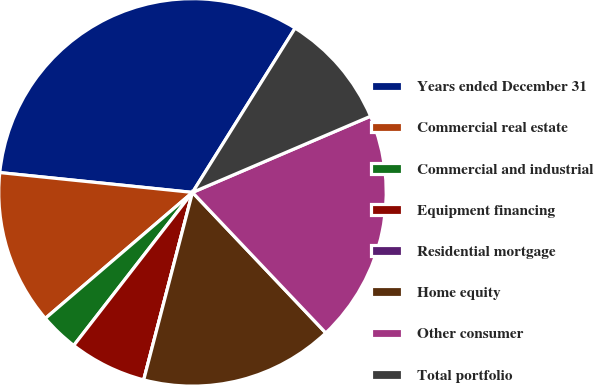<chart> <loc_0><loc_0><loc_500><loc_500><pie_chart><fcel>Years ended December 31<fcel>Commercial real estate<fcel>Commercial and industrial<fcel>Equipment financing<fcel>Residential mortgage<fcel>Home equity<fcel>Other consumer<fcel>Total portfolio<nl><fcel>32.25%<fcel>12.9%<fcel>3.23%<fcel>6.45%<fcel>0.0%<fcel>16.13%<fcel>19.35%<fcel>9.68%<nl></chart> 